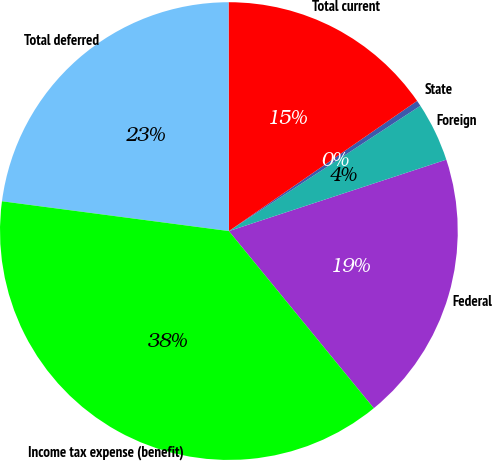<chart> <loc_0><loc_0><loc_500><loc_500><pie_chart><fcel>Federal<fcel>Foreign<fcel>State<fcel>Total current<fcel>Total deferred<fcel>Income tax expense (benefit)<nl><fcel>19.14%<fcel>4.17%<fcel>0.41%<fcel>15.39%<fcel>22.9%<fcel>37.99%<nl></chart> 